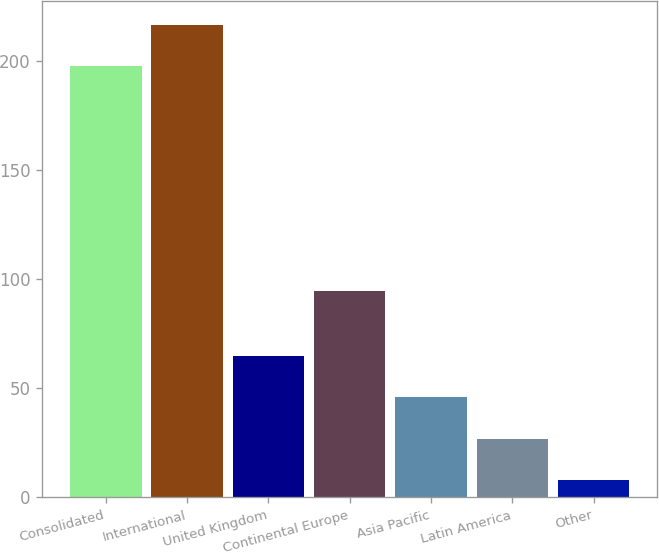<chart> <loc_0><loc_0><loc_500><loc_500><bar_chart><fcel>Consolidated<fcel>International<fcel>United Kingdom<fcel>Continental Europe<fcel>Asia Pacific<fcel>Latin America<fcel>Other<nl><fcel>197.5<fcel>216.46<fcel>64.78<fcel>94.4<fcel>45.82<fcel>26.86<fcel>7.9<nl></chart> 